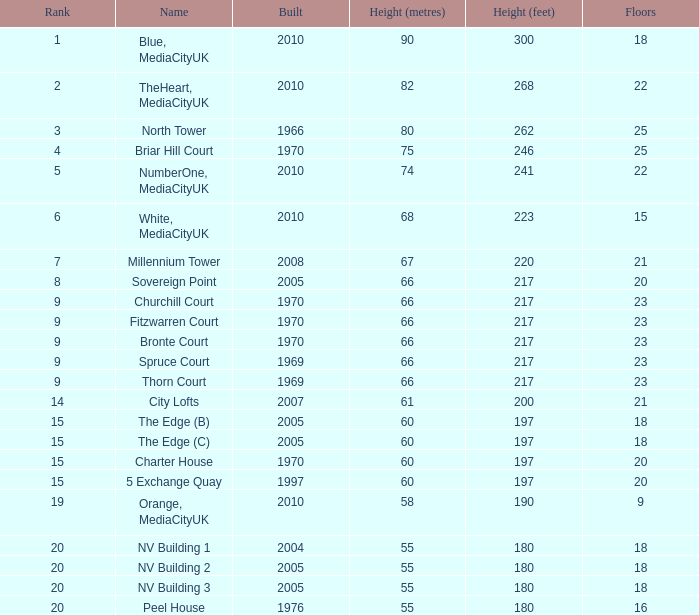What is the lowest Floors, when Built is greater than 1970, and when Name is NV Building 3? 18.0. Can you give me this table as a dict? {'header': ['Rank', 'Name', 'Built', 'Height (metres)', 'Height (feet)', 'Floors'], 'rows': [['1', 'Blue, MediaCityUK', '2010', '90', '300', '18'], ['2', 'TheHeart, MediaCityUK', '2010', '82', '268', '22'], ['3', 'North Tower', '1966', '80', '262', '25'], ['4', 'Briar Hill Court', '1970', '75', '246', '25'], ['5', 'NumberOne, MediaCityUK', '2010', '74', '241', '22'], ['6', 'White, MediaCityUK', '2010', '68', '223', '15'], ['7', 'Millennium Tower', '2008', '67', '220', '21'], ['8', 'Sovereign Point', '2005', '66', '217', '20'], ['9', 'Churchill Court', '1970', '66', '217', '23'], ['9', 'Fitzwarren Court', '1970', '66', '217', '23'], ['9', 'Bronte Court', '1970', '66', '217', '23'], ['9', 'Spruce Court', '1969', '66', '217', '23'], ['9', 'Thorn Court', '1969', '66', '217', '23'], ['14', 'City Lofts', '2007', '61', '200', '21'], ['15', 'The Edge (B)', '2005', '60', '197', '18'], ['15', 'The Edge (C)', '2005', '60', '197', '18'], ['15', 'Charter House', '1970', '60', '197', '20'], ['15', '5 Exchange Quay', '1997', '60', '197', '20'], ['19', 'Orange, MediaCityUK', '2010', '58', '190', '9'], ['20', 'NV Building 1', '2004', '55', '180', '18'], ['20', 'NV Building 2', '2005', '55', '180', '18'], ['20', 'NV Building 3', '2005', '55', '180', '18'], ['20', 'Peel House', '1976', '55', '180', '16']]} 